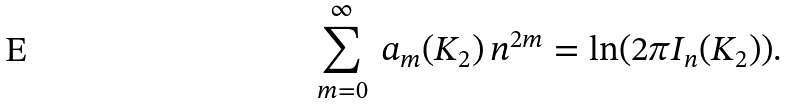Convert formula to latex. <formula><loc_0><loc_0><loc_500><loc_500>\sum _ { m = 0 } ^ { \infty } \ a _ { m } ( K _ { 2 } ) \, n ^ { 2 m } = \ln ( 2 \pi I _ { n } ( K _ { 2 } ) ) .</formula> 